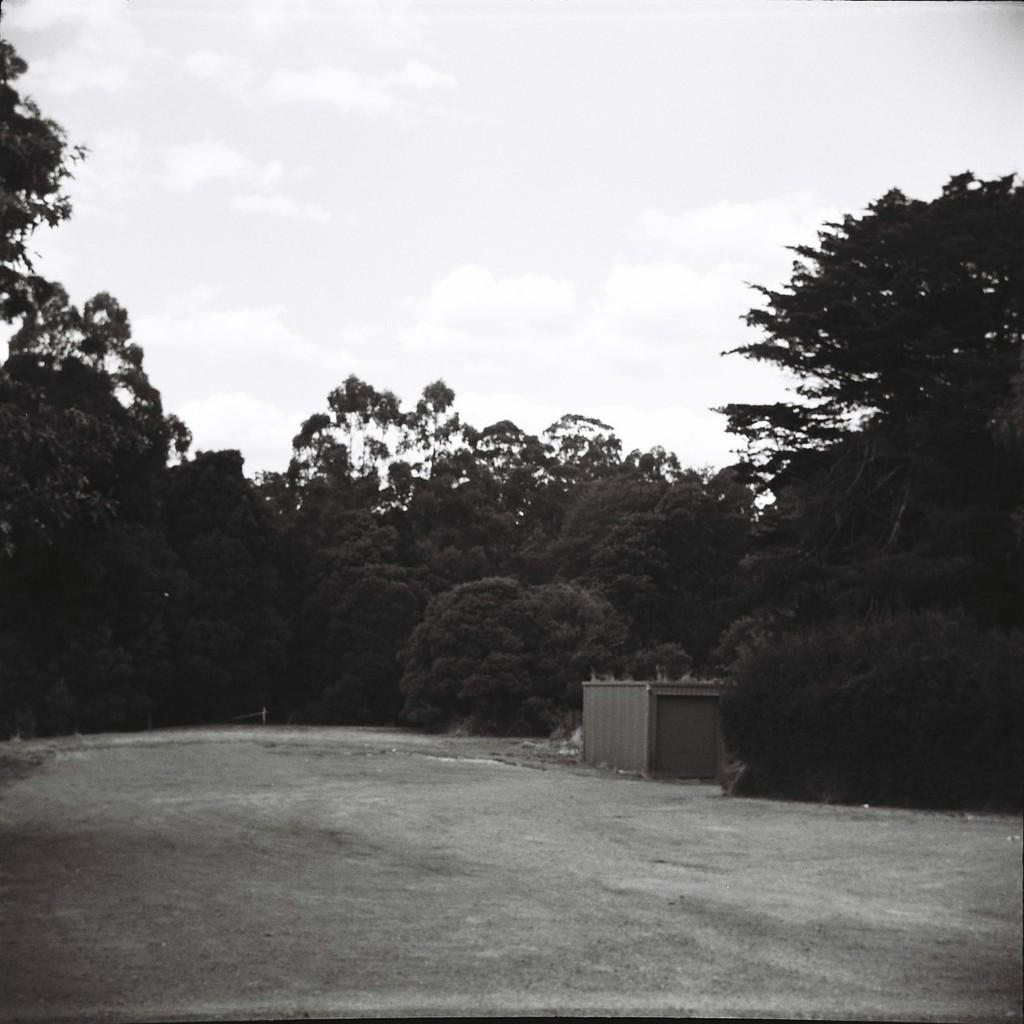What structure is present in the image? There is a shed in the image. How is the shed positioned in the image? The shed is placed on the ground. What can be seen in the background of the image? There is a group of trees and the sky visible in the background of the image. How does the shed maintain its balance during the earthquake in the image? There is no earthquake present in the image, so the shed's balance is not affected. 